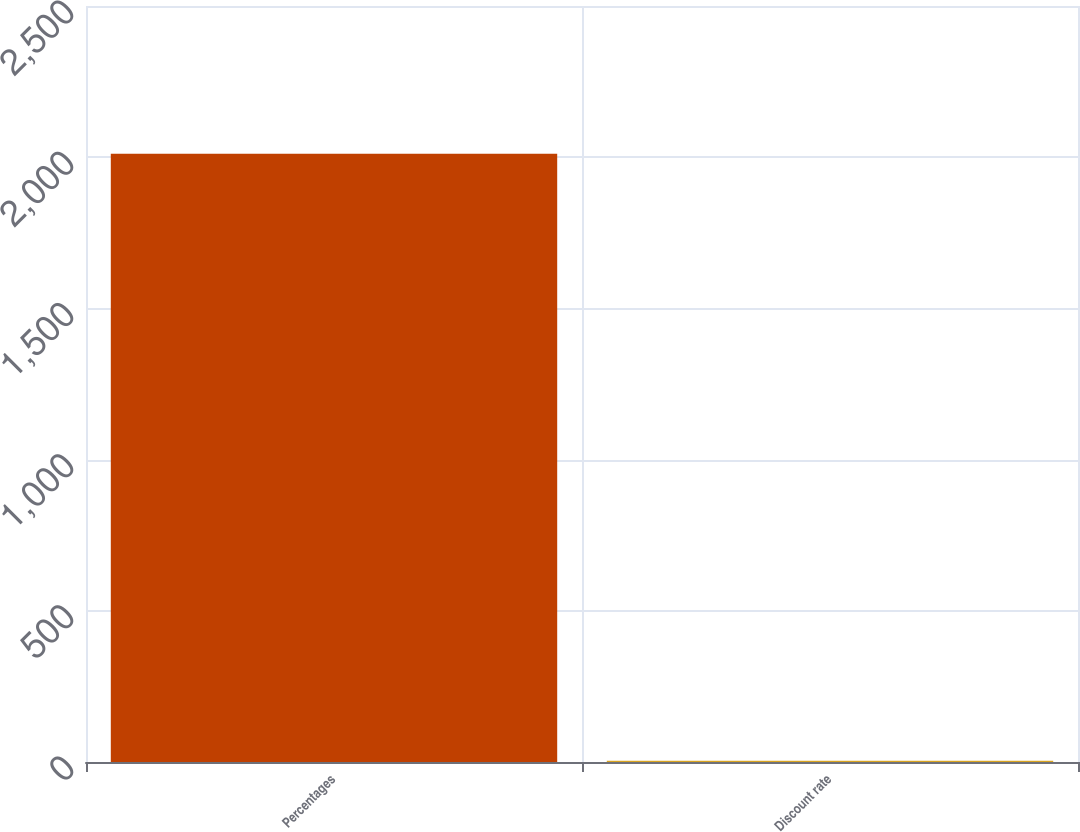Convert chart to OTSL. <chart><loc_0><loc_0><loc_500><loc_500><bar_chart><fcel>Percentages<fcel>Discount rate<nl><fcel>2011<fcel>4.36<nl></chart> 